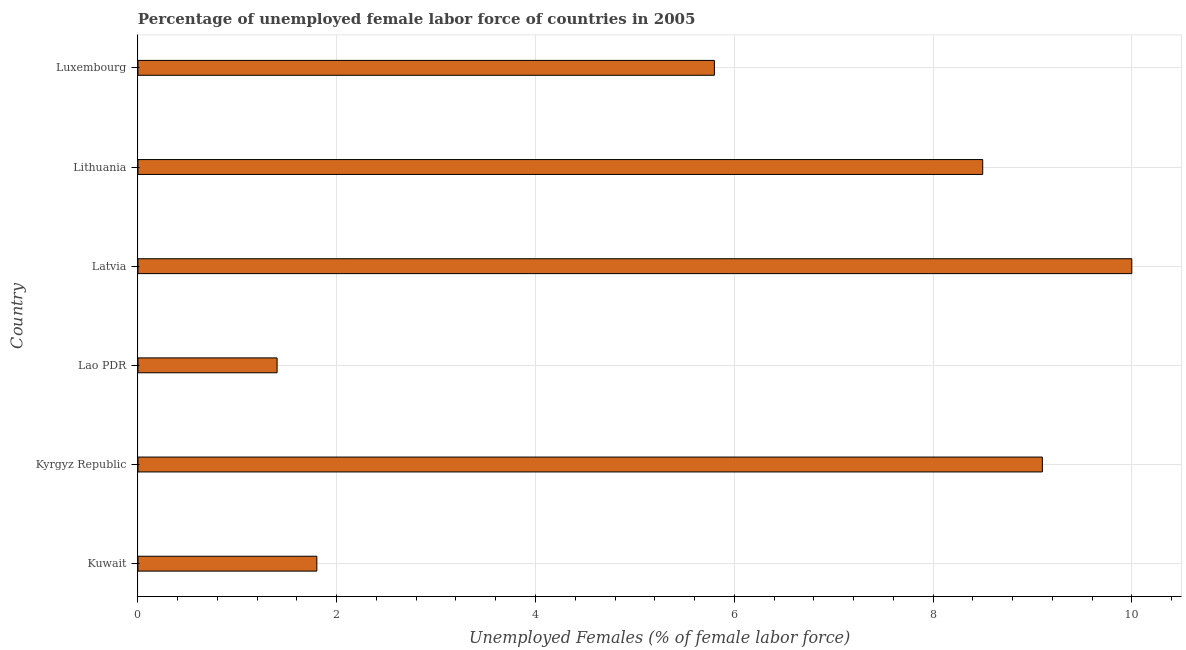Does the graph contain grids?
Your response must be concise. Yes. What is the title of the graph?
Your answer should be very brief. Percentage of unemployed female labor force of countries in 2005. What is the label or title of the X-axis?
Your answer should be compact. Unemployed Females (% of female labor force). What is the total unemployed female labour force in Lithuania?
Keep it short and to the point. 8.5. Across all countries, what is the maximum total unemployed female labour force?
Your answer should be very brief. 10. Across all countries, what is the minimum total unemployed female labour force?
Provide a short and direct response. 1.4. In which country was the total unemployed female labour force maximum?
Your answer should be compact. Latvia. In which country was the total unemployed female labour force minimum?
Give a very brief answer. Lao PDR. What is the sum of the total unemployed female labour force?
Ensure brevity in your answer.  36.6. What is the median total unemployed female labour force?
Make the answer very short. 7.15. What is the ratio of the total unemployed female labour force in Kyrgyz Republic to that in Lithuania?
Ensure brevity in your answer.  1.07. Is the difference between the total unemployed female labour force in Lao PDR and Luxembourg greater than the difference between any two countries?
Offer a very short reply. No. What is the difference between the highest and the second highest total unemployed female labour force?
Your response must be concise. 0.9. What is the difference between the highest and the lowest total unemployed female labour force?
Provide a succinct answer. 8.6. How many countries are there in the graph?
Provide a succinct answer. 6. What is the difference between two consecutive major ticks on the X-axis?
Offer a terse response. 2. Are the values on the major ticks of X-axis written in scientific E-notation?
Your answer should be very brief. No. What is the Unemployed Females (% of female labor force) in Kuwait?
Offer a terse response. 1.8. What is the Unemployed Females (% of female labor force) of Kyrgyz Republic?
Make the answer very short. 9.1. What is the Unemployed Females (% of female labor force) of Lao PDR?
Your answer should be very brief. 1.4. What is the Unemployed Females (% of female labor force) in Luxembourg?
Keep it short and to the point. 5.8. What is the difference between the Unemployed Females (% of female labor force) in Kuwait and Kyrgyz Republic?
Keep it short and to the point. -7.3. What is the difference between the Unemployed Females (% of female labor force) in Kuwait and Lao PDR?
Keep it short and to the point. 0.4. What is the difference between the Unemployed Females (% of female labor force) in Kuwait and Latvia?
Your response must be concise. -8.2. What is the difference between the Unemployed Females (% of female labor force) in Kuwait and Lithuania?
Offer a terse response. -6.7. What is the difference between the Unemployed Females (% of female labor force) in Kyrgyz Republic and Lithuania?
Ensure brevity in your answer.  0.6. What is the difference between the Unemployed Females (% of female labor force) in Lao PDR and Luxembourg?
Offer a very short reply. -4.4. What is the difference between the Unemployed Females (% of female labor force) in Latvia and Lithuania?
Provide a short and direct response. 1.5. What is the difference between the Unemployed Females (% of female labor force) in Latvia and Luxembourg?
Provide a succinct answer. 4.2. What is the ratio of the Unemployed Females (% of female labor force) in Kuwait to that in Kyrgyz Republic?
Provide a succinct answer. 0.2. What is the ratio of the Unemployed Females (% of female labor force) in Kuwait to that in Lao PDR?
Offer a very short reply. 1.29. What is the ratio of the Unemployed Females (% of female labor force) in Kuwait to that in Latvia?
Offer a terse response. 0.18. What is the ratio of the Unemployed Females (% of female labor force) in Kuwait to that in Lithuania?
Offer a terse response. 0.21. What is the ratio of the Unemployed Females (% of female labor force) in Kuwait to that in Luxembourg?
Your answer should be very brief. 0.31. What is the ratio of the Unemployed Females (% of female labor force) in Kyrgyz Republic to that in Latvia?
Your answer should be very brief. 0.91. What is the ratio of the Unemployed Females (% of female labor force) in Kyrgyz Republic to that in Lithuania?
Provide a short and direct response. 1.07. What is the ratio of the Unemployed Females (% of female labor force) in Kyrgyz Republic to that in Luxembourg?
Your answer should be very brief. 1.57. What is the ratio of the Unemployed Females (% of female labor force) in Lao PDR to that in Latvia?
Keep it short and to the point. 0.14. What is the ratio of the Unemployed Females (% of female labor force) in Lao PDR to that in Lithuania?
Your answer should be compact. 0.17. What is the ratio of the Unemployed Females (% of female labor force) in Lao PDR to that in Luxembourg?
Ensure brevity in your answer.  0.24. What is the ratio of the Unemployed Females (% of female labor force) in Latvia to that in Lithuania?
Provide a succinct answer. 1.18. What is the ratio of the Unemployed Females (% of female labor force) in Latvia to that in Luxembourg?
Provide a short and direct response. 1.72. What is the ratio of the Unemployed Females (% of female labor force) in Lithuania to that in Luxembourg?
Your answer should be very brief. 1.47. 